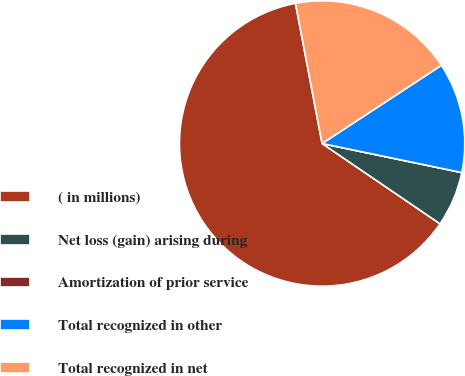<chart> <loc_0><loc_0><loc_500><loc_500><pie_chart><fcel>( in millions)<fcel>Net loss (gain) arising during<fcel>Amortization of prior service<fcel>Total recognized in other<fcel>Total recognized in net<nl><fcel>62.49%<fcel>6.25%<fcel>0.0%<fcel>12.5%<fcel>18.75%<nl></chart> 